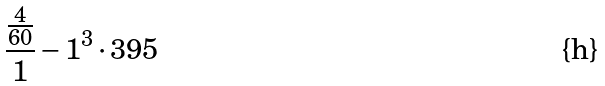Convert formula to latex. <formula><loc_0><loc_0><loc_500><loc_500>\frac { \frac { 4 } { 6 0 } } { 1 } - 1 ^ { 3 } \cdot 3 9 5</formula> 